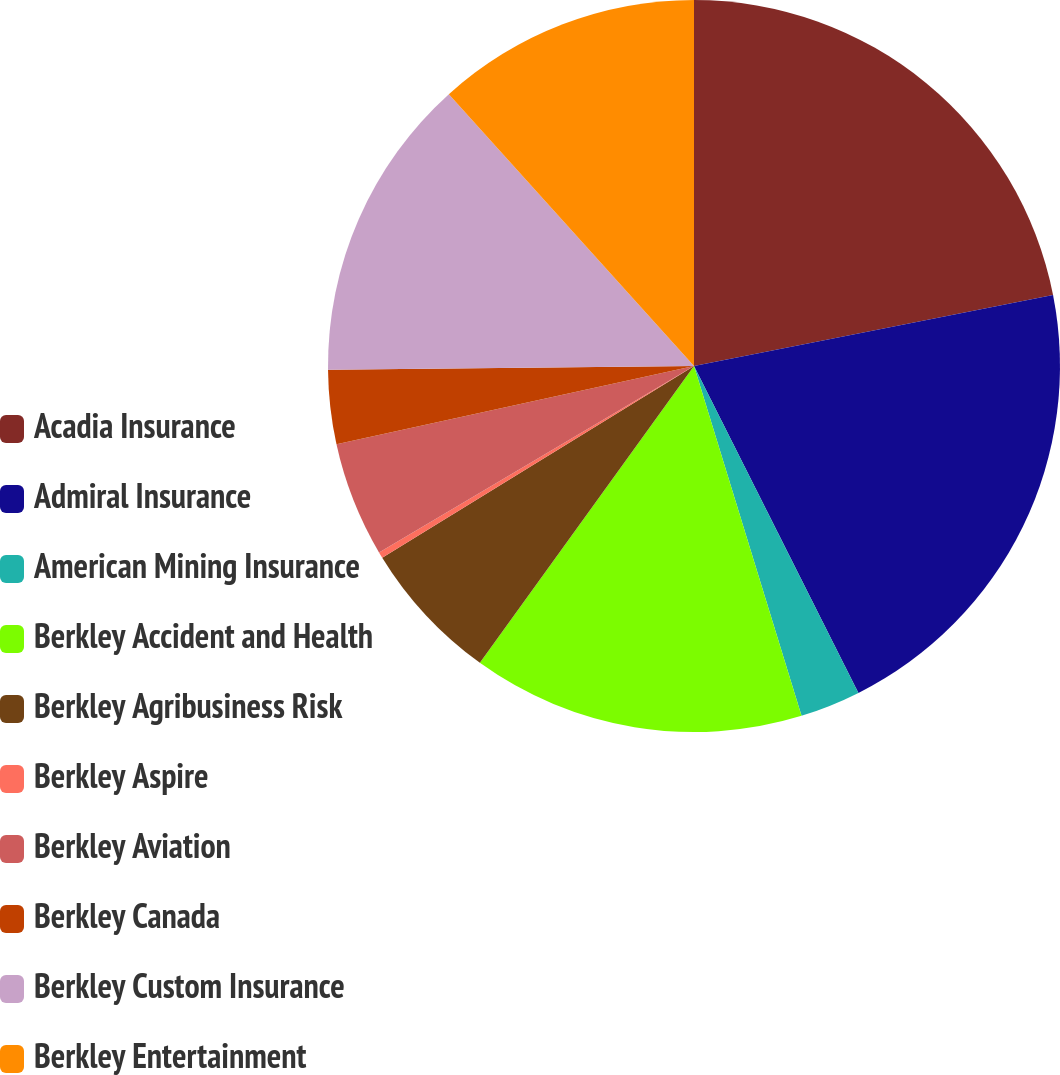<chart> <loc_0><loc_0><loc_500><loc_500><pie_chart><fcel>Acadia Insurance<fcel>Admiral Insurance<fcel>American Mining Insurance<fcel>Berkley Accident and Health<fcel>Berkley Agribusiness Risk<fcel>Berkley Aspire<fcel>Berkley Aviation<fcel>Berkley Canada<fcel>Berkley Custom Insurance<fcel>Berkley Entertainment<nl><fcel>21.89%<fcel>20.69%<fcel>2.67%<fcel>14.69%<fcel>6.28%<fcel>0.27%<fcel>5.07%<fcel>3.27%<fcel>13.48%<fcel>11.68%<nl></chart> 